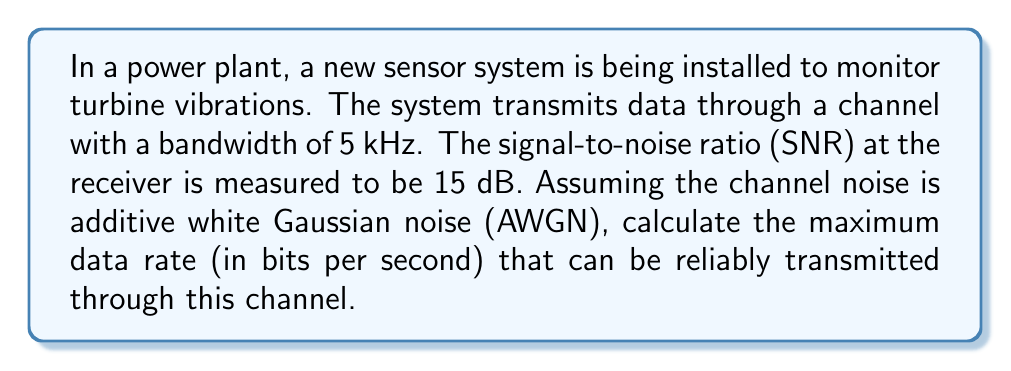Teach me how to tackle this problem. To solve this problem, we'll use the Shannon-Hartley theorem, which gives the channel capacity for an AWGN channel. The theorem states:

$$C = B \log_2(1 + SNR)$$

Where:
$C$ is the channel capacity in bits per second (bps)
$B$ is the channel bandwidth in Hz
$SNR$ is the signal-to-noise ratio (linear, not dB)

Step 1: Convert the given SNR from dB to linear scale
SNR (dB) = 15 dB
SNR (linear) = $10^{(SNR_{dB}/10)} = 10^{(15/10)} = 10^{1.5} \approx 31.6228$

Step 2: Apply the Shannon-Hartley theorem
$B = 5 \text{ kHz} = 5000 \text{ Hz}$
$SNR = 31.6228$

$$\begin{align}
C &= B \log_2(1 + SNR) \\
&= 5000 \log_2(1 + 31.6228) \\
&= 5000 \log_2(32.6228) \\
&\approx 5000 \cdot 5.0279 \\
&\approx 25139.5 \text{ bps}
\end{align}$$

Step 3: Round to the nearest whole number
$C \approx 25140 \text{ bps}$

This result represents the theoretical maximum data rate that can be reliably transmitted through the given channel under the specified conditions.
Answer: The maximum data rate that can be reliably transmitted through the channel is approximately 25140 bits per second (bps). 